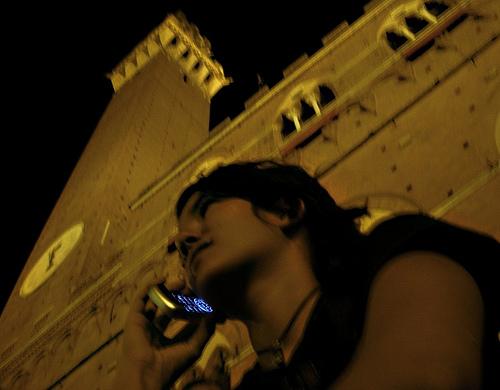Is the girl wearing a necklace?
Be succinct. Yes. Is this person wearing safety gear?
Give a very brief answer. No. Is she wearing a hood?
Give a very brief answer. No. What is wrapped around his neck?
Concise answer only. Necklace. Is it nighttime?
Short answer required. Yes. What time is it?
Be succinct. Night. What is the woman holding?
Answer briefly. Phone. 